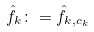Convert formula to latex. <formula><loc_0><loc_0><loc_500><loc_500>\hat { f } _ { k } \colon = \hat { f } _ { k , c _ { k } }</formula> 